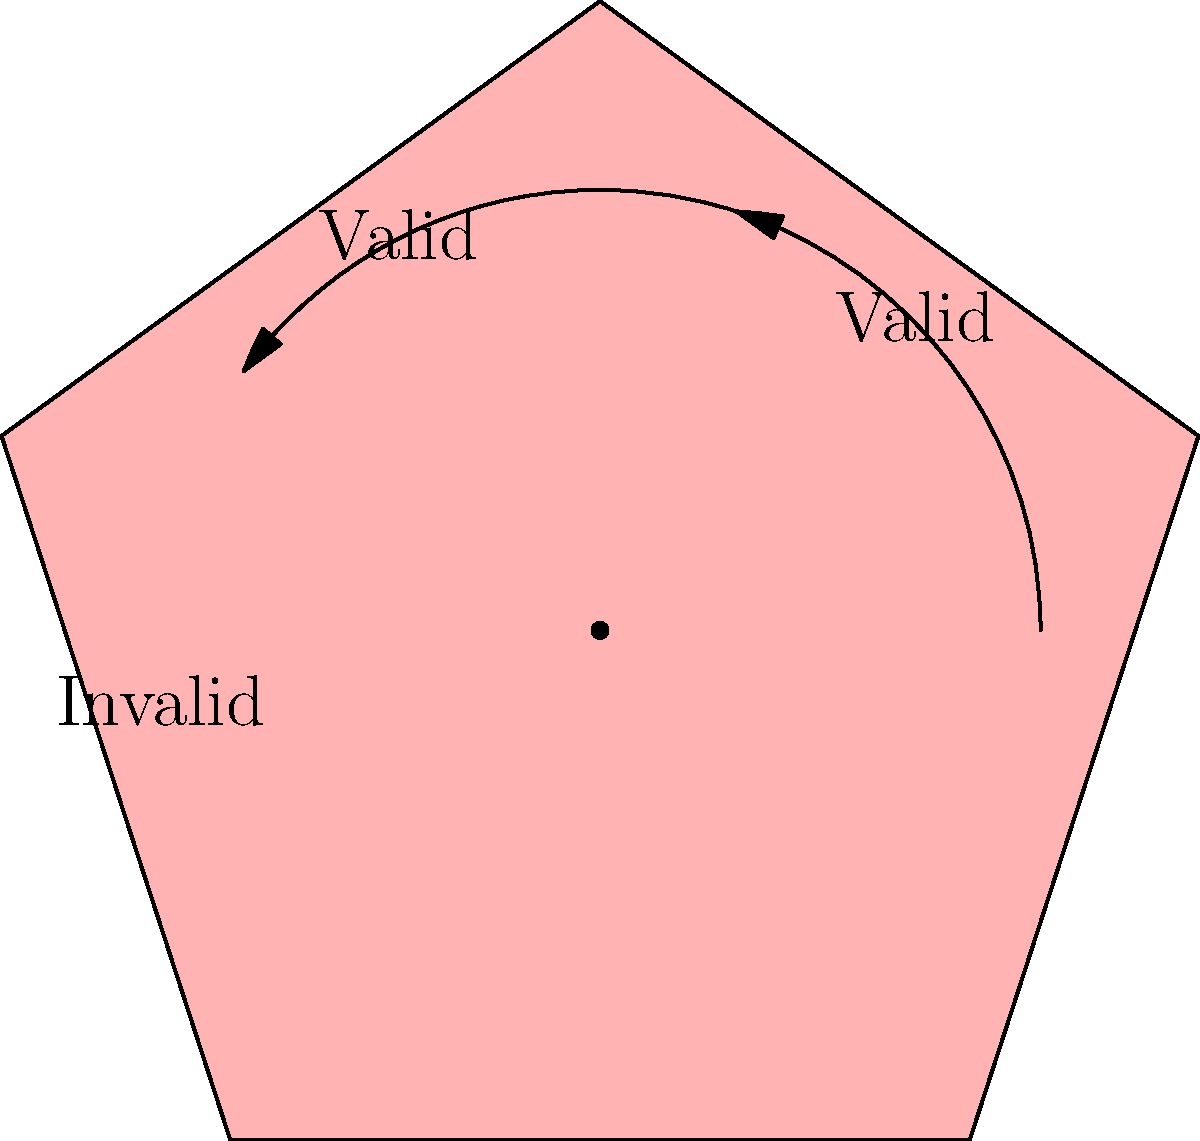A pentagon-shaped event ticket is designed to be rotated around its center point for entry validation. If the ticket is valid when rotated $0°$ or $72°$ clockwise, but invalid at $144°$, what is the minimum number of unique valid positions for the ticket in a complete $360°$ rotation? Let's approach this step-by-step:

1) We're told that the ticket is valid at $0°$ and $72°$ rotations, but invalid at $144°$.

2) The ticket is a pentagon, which has rotational symmetry of order 5. This means that a full rotation of $360°$ can be divided into 5 equal parts, each of $72°$.

3) Given the information, we can deduce the following:
   - $0°$ rotation: Valid
   - $72°$ rotation: Valid
   - $144°$ rotation: Invalid
   
4) Due to the rotational symmetry of the pentagon, this pattern will repeat every $144°$. So we can extend our findings:
   - $0°$ rotation: Valid
   - $72°$ rotation: Valid
   - $144°$ rotation: Invalid
   - $216°$ rotation: Valid
   - $288°$ rotation: Valid

5) After a full $360°$ rotation, we're back to the starting position.

6) Counting the valid positions, we find that there are 4 unique valid positions: $0°$, $72°$, $216°$, and $288°$.

Therefore, the minimum number of unique valid positions for the ticket in a complete $360°$ rotation is 4.
Answer: 4 